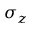Convert formula to latex. <formula><loc_0><loc_0><loc_500><loc_500>\sigma _ { z }</formula> 